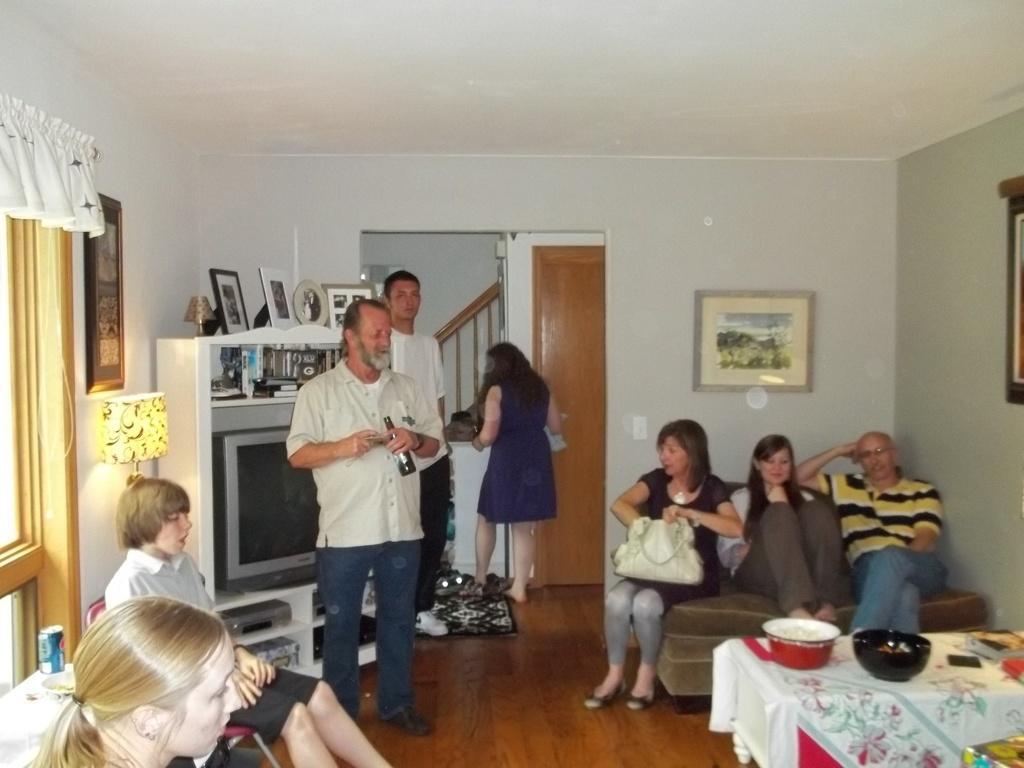Please provide a concise description of this image. In this image it seems like there are few people who are sitting in sofa and few people standing near window. At the back side there is television which is kept in shelf. There are books and photo frames above the television and there is a lamp to the left side of the image. There is a photo frame attached to the wall. To the right side there is a table on which there are bowls. 